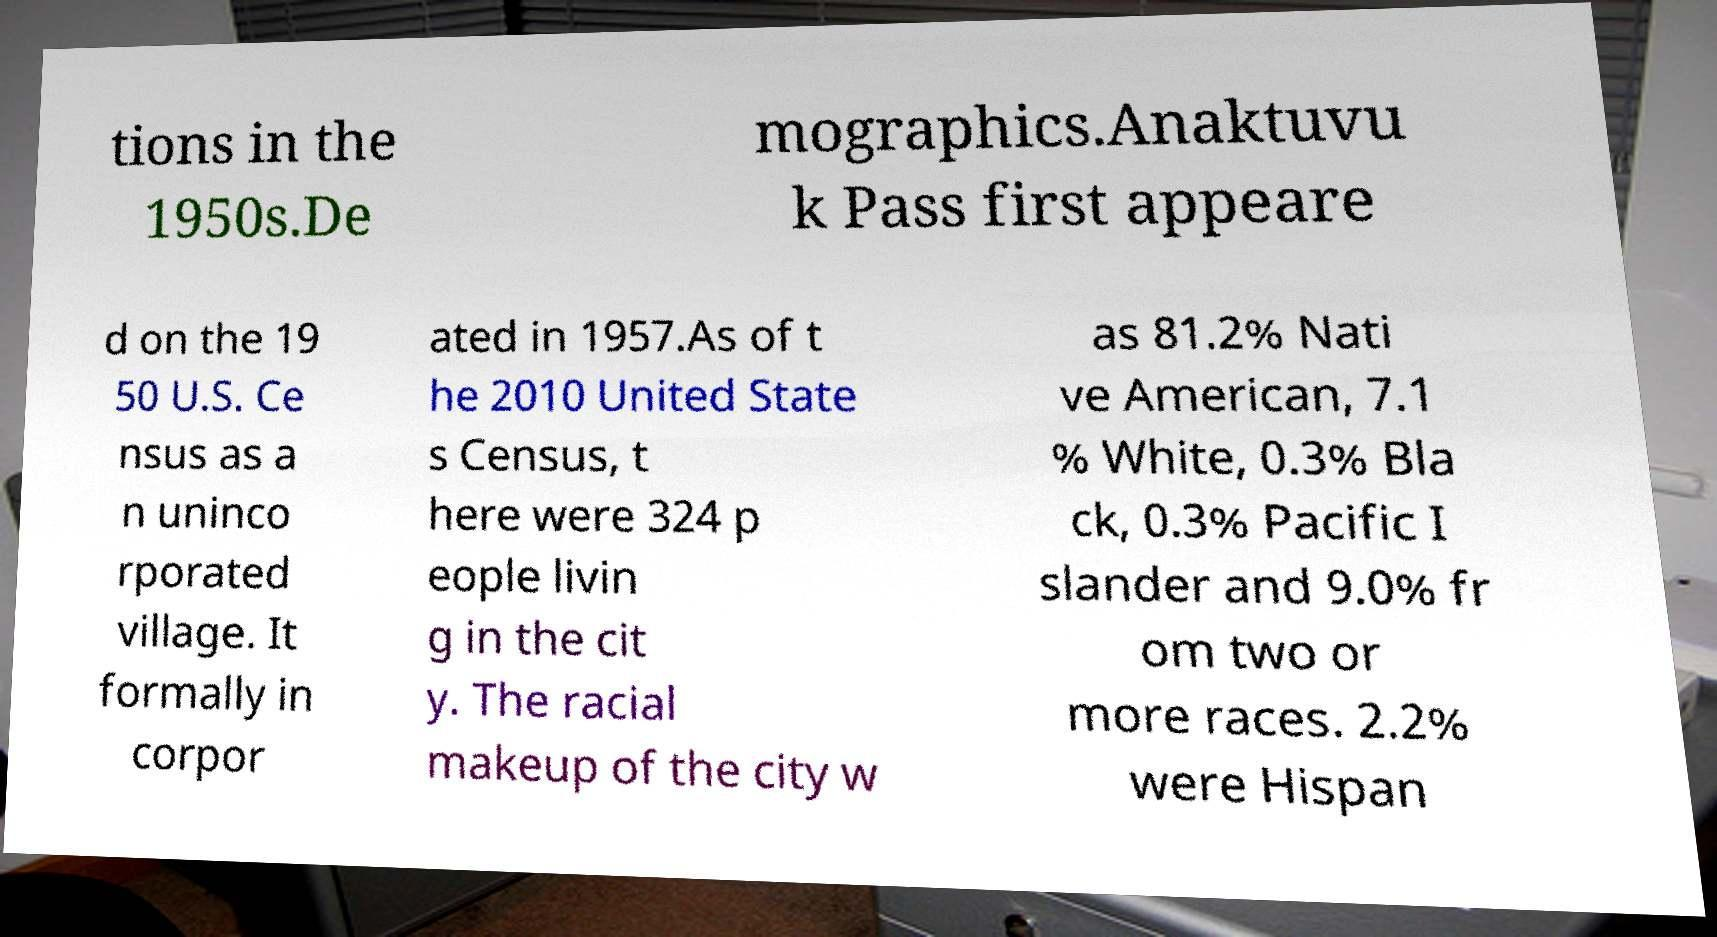Please read and relay the text visible in this image. What does it say? tions in the 1950s.De mographics.Anaktuvu k Pass first appeare d on the 19 50 U.S. Ce nsus as a n uninco rporated village. It formally in corpor ated in 1957.As of t he 2010 United State s Census, t here were 324 p eople livin g in the cit y. The racial makeup of the city w as 81.2% Nati ve American, 7.1 % White, 0.3% Bla ck, 0.3% Pacific I slander and 9.0% fr om two or more races. 2.2% were Hispan 